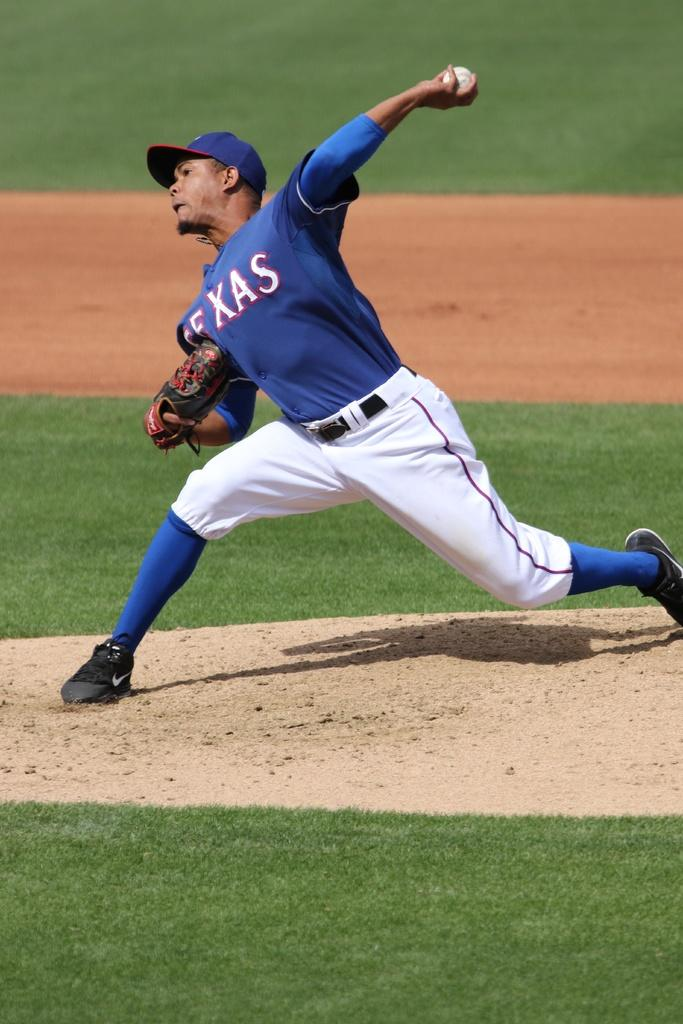<image>
Describe the image concisely. The pitcher from the Texas team is winding up for a pitch. 